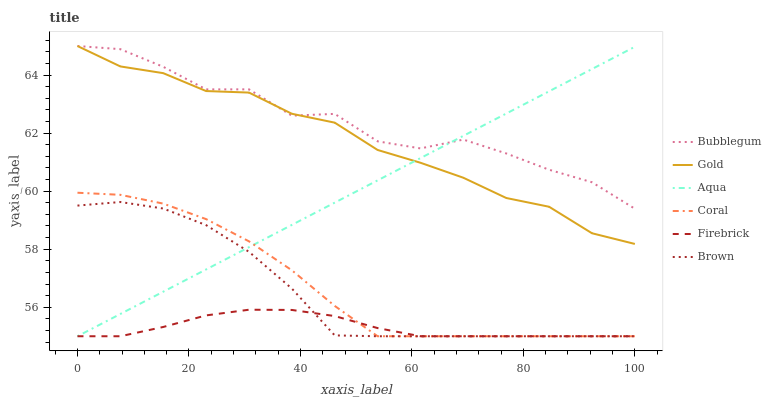Does Firebrick have the minimum area under the curve?
Answer yes or no. Yes. Does Bubblegum have the maximum area under the curve?
Answer yes or no. Yes. Does Gold have the minimum area under the curve?
Answer yes or no. No. Does Gold have the maximum area under the curve?
Answer yes or no. No. Is Aqua the smoothest?
Answer yes or no. Yes. Is Bubblegum the roughest?
Answer yes or no. Yes. Is Gold the smoothest?
Answer yes or no. No. Is Gold the roughest?
Answer yes or no. No. Does Brown have the lowest value?
Answer yes or no. Yes. Does Gold have the lowest value?
Answer yes or no. No. Does Bubblegum have the highest value?
Answer yes or no. Yes. Does Firebrick have the highest value?
Answer yes or no. No. Is Brown less than Bubblegum?
Answer yes or no. Yes. Is Bubblegum greater than Brown?
Answer yes or no. Yes. Does Brown intersect Coral?
Answer yes or no. Yes. Is Brown less than Coral?
Answer yes or no. No. Is Brown greater than Coral?
Answer yes or no. No. Does Brown intersect Bubblegum?
Answer yes or no. No. 